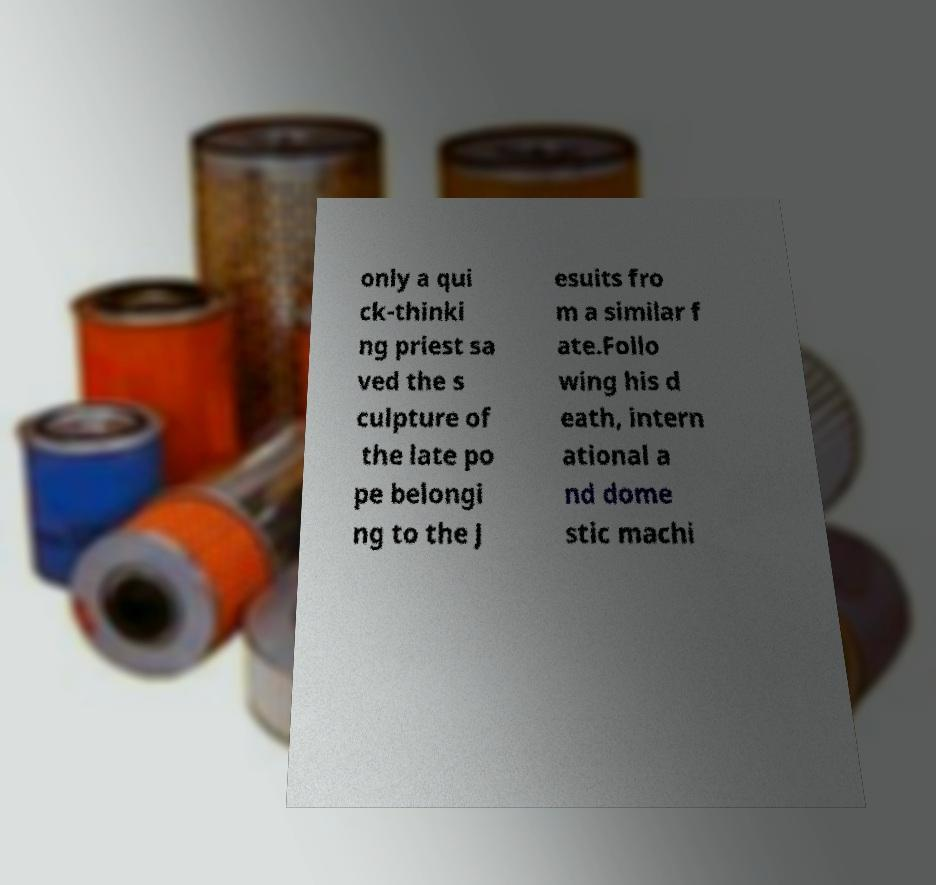Could you assist in decoding the text presented in this image and type it out clearly? only a qui ck-thinki ng priest sa ved the s culpture of the late po pe belongi ng to the J esuits fro m a similar f ate.Follo wing his d eath, intern ational a nd dome stic machi 